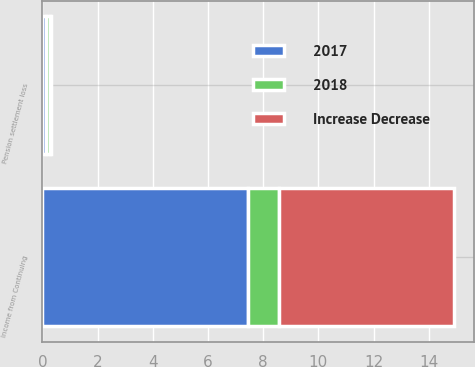<chart> <loc_0><loc_0><loc_500><loc_500><stacked_bar_chart><ecel><fcel>Income from Continuing<fcel>Pension settlement loss<nl><fcel>2017<fcel>7.45<fcel>0.15<nl><fcel>Increase Decrease<fcel>6.31<fcel>0.03<nl><fcel>2018<fcel>1.14<fcel>0.12<nl></chart> 